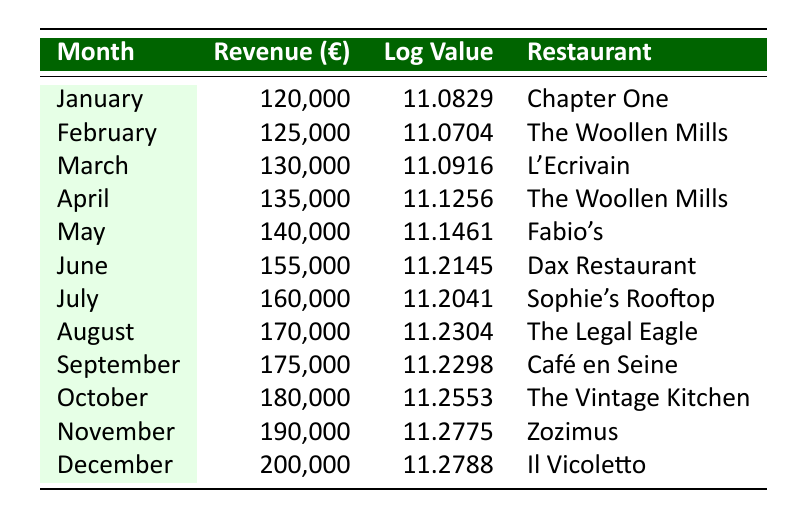What was the revenue for July? The table indicates that the revenue for July is listed alongside the month. Referring directly to the row for July, the revenue is stated as 160,000.
Answer: 160,000 Which restaurant had the highest revenue in December? The last row of the table for December lists the restaurant Il Vicoletto, which had the highest revenue for that month amounting to 200,000.
Answer: Il Vicoletto What is the total revenue for the first half of the year (January to June)? To find the total revenue for the first half of the year, we need to sum the revenues from January to June. This gives us 120,000 (Jan) + 125,000 (Feb) + 130,000 (Mar) + 135,000 (Apr) + 140,000 (May) + 155,000 (Jun) = 905,000.
Answer: 905,000 Did Café en Seine earn more revenue in September than Dax Restaurant did in June? Looking at the table, Café en Seine earned 175,000 in September, while Dax Restaurant earned 155,000 in June. Since 175,000 is greater than 155,000, the answer is yes.
Answer: Yes What was the average revenue from March to May? To calculate the average revenue, first sum the revenues from March (130,000), April (135,000), and May (140,000): 130,000 + 135,000 + 140,000 = 405,000. Then divide by the number of months, which is 3: 405,000 / 3 = 135,000.
Answer: 135,000 Which month experienced the largest increase in revenue compared to the previous month? First, we need to calculate the monthly increases in revenue: February - January = 5,000, March - February = 5,000, April - March = 5,000, May - April = 5,000, June - May = 15,000, July - June = 5,000, August - July = 10,000, September - August = 5,000, October - September = 5,000, November - October = 10,000, December - November = 10,000. The largest increase is from May to June, which is 15,000.
Answer: June Was the revenue in October greater than the revenue in both July and August combined? Adding together the revenues of July (160,000) and August (170,000) gives 330,000. The revenue for October is 180,000. Since 180,000 is less than 330,000, the answer is no.
Answer: No What was the logarithmic value for the restaurant with the lowest revenue in January? Referring to the table, Chapter One generated 120,000 in revenue for January, and its logarithmic value is listed as 11.0829.
Answer: 11.0829 